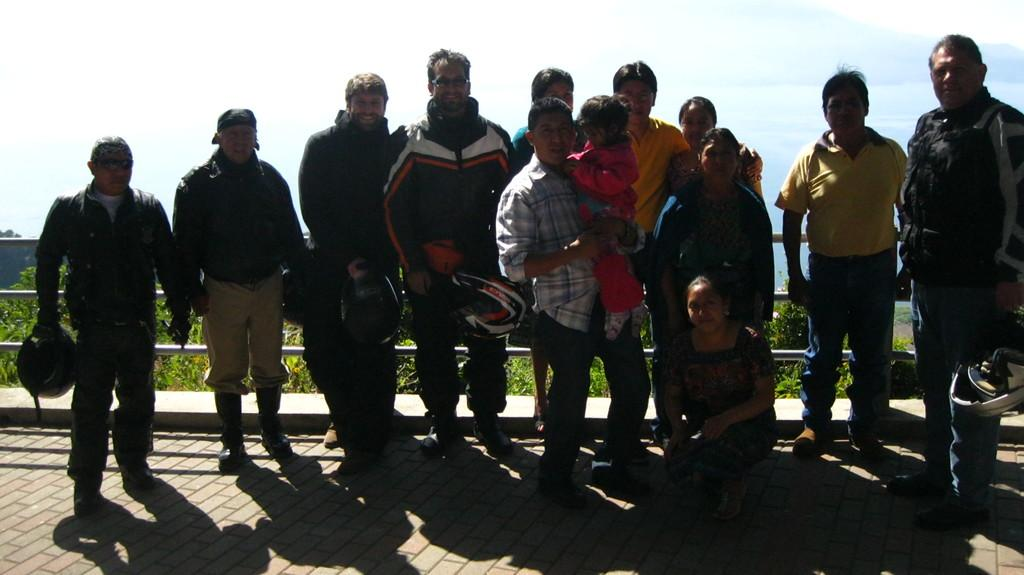What are the persons in the image doing? The persons in the image are giving a pose for a photograph. What can be seen in the background of the image? In the background, there are iron roads and trees. What is the condition of the sky in the image? The sky is visible in the background and appears cloudy. What type of pancake is being flipped in the image? There is no pancake present in the image; the persons are posing for a photograph. Can you see any visible teeth in the image? There are no teeth visible in the image, as it features persons posing for a photograph and not any close-up shots of faces. 